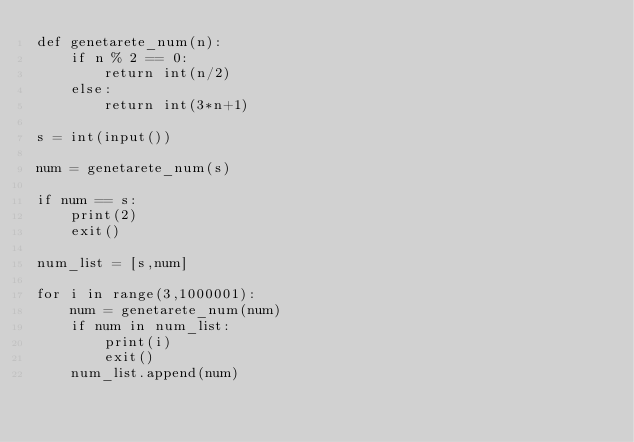Convert code to text. <code><loc_0><loc_0><loc_500><loc_500><_Python_>def genetarete_num(n):
    if n % 2 == 0:
        return int(n/2)
    else:
        return int(3*n+1)

s = int(input())

num = genetarete_num(s)

if num == s:
    print(2)
    exit()

num_list = [s,num]

for i in range(3,1000001):
    num = genetarete_num(num)
    if num in num_list:
        print(i)
        exit()
    num_list.append(num)
</code> 